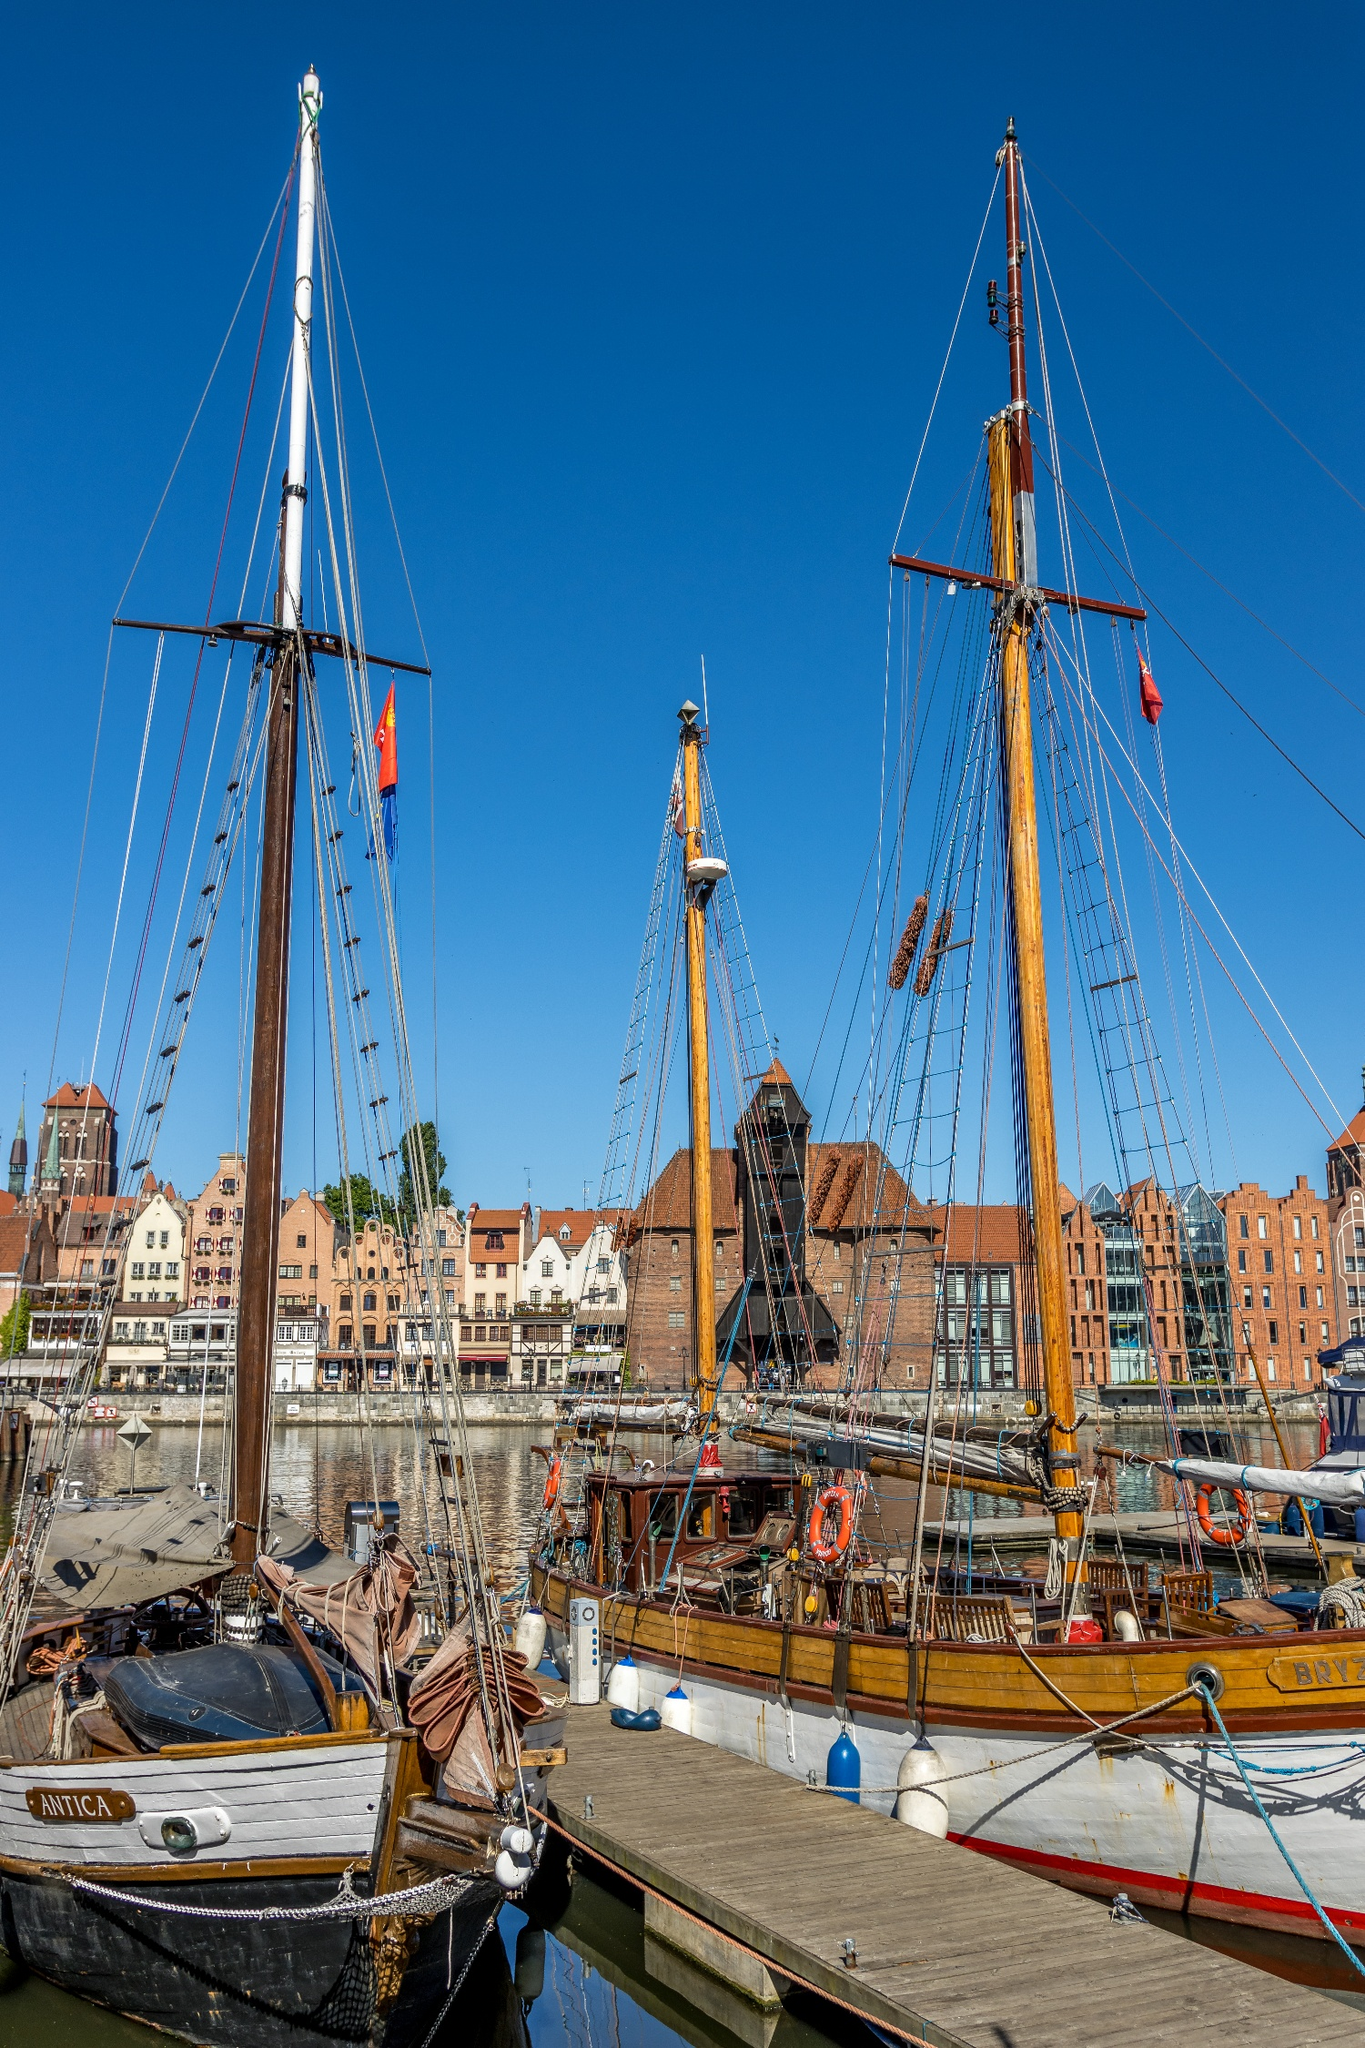What details can you tell me about the ships in the foreground? The foremost ships in the image are traditional wooden sailing vessels, likely used historically for trade or exploration. The ship named Antica has a robust wooden hull and is equipped with a full set of sails, held aloft by tall masts made of what appears to be varnished wood, giving it a historical and well-preserved appearance. The riggings are complex, illustrating its functionality for sailing. These ships also display various colorful flags that might represent either their origin or participation in a specific event. 